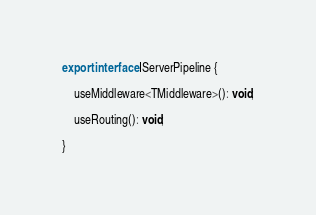Convert code to text. <code><loc_0><loc_0><loc_500><loc_500><_TypeScript_>

export interface IServerPipeline {

    useMiddleware<TMiddleware>(): void;

    useRouting(): void;

}</code> 